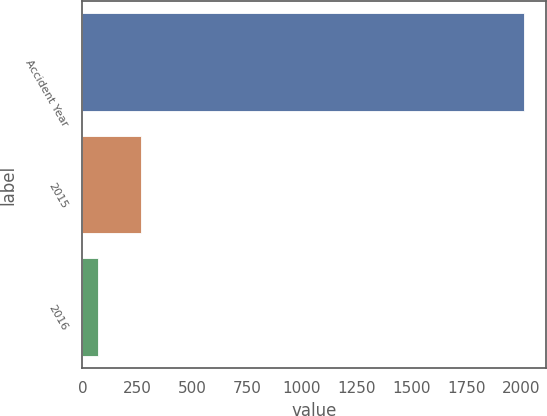<chart> <loc_0><loc_0><loc_500><loc_500><bar_chart><fcel>Accident Year<fcel>2015<fcel>2016<nl><fcel>2016<fcel>265.5<fcel>71<nl></chart> 